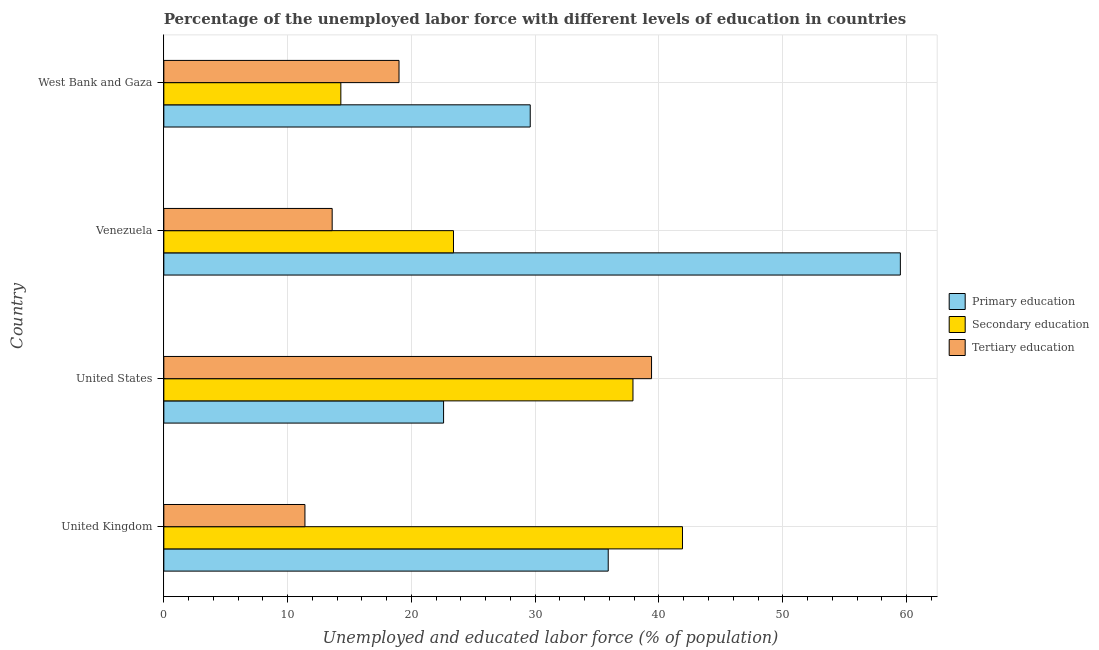How many groups of bars are there?
Make the answer very short. 4. Are the number of bars per tick equal to the number of legend labels?
Provide a succinct answer. Yes. Are the number of bars on each tick of the Y-axis equal?
Ensure brevity in your answer.  Yes. How many bars are there on the 2nd tick from the top?
Keep it short and to the point. 3. What is the percentage of labor force who received primary education in West Bank and Gaza?
Your response must be concise. 29.6. Across all countries, what is the maximum percentage of labor force who received tertiary education?
Make the answer very short. 39.4. Across all countries, what is the minimum percentage of labor force who received tertiary education?
Offer a terse response. 11.4. In which country was the percentage of labor force who received secondary education maximum?
Your answer should be very brief. United Kingdom. In which country was the percentage of labor force who received primary education minimum?
Your answer should be compact. United States. What is the total percentage of labor force who received tertiary education in the graph?
Your response must be concise. 83.4. What is the difference between the percentage of labor force who received primary education in Venezuela and that in West Bank and Gaza?
Provide a short and direct response. 29.9. What is the difference between the percentage of labor force who received secondary education in United Kingdom and the percentage of labor force who received tertiary education in West Bank and Gaza?
Ensure brevity in your answer.  22.9. What is the average percentage of labor force who received primary education per country?
Your answer should be very brief. 36.9. What is the difference between the percentage of labor force who received tertiary education and percentage of labor force who received secondary education in United Kingdom?
Your response must be concise. -30.5. In how many countries, is the percentage of labor force who received primary education greater than 50 %?
Ensure brevity in your answer.  1. What is the ratio of the percentage of labor force who received tertiary education in Venezuela to that in West Bank and Gaza?
Your answer should be compact. 0.72. What is the difference between the highest and the second highest percentage of labor force who received tertiary education?
Your response must be concise. 20.4. What is the difference between the highest and the lowest percentage of labor force who received tertiary education?
Ensure brevity in your answer.  28. Is the sum of the percentage of labor force who received secondary education in Venezuela and West Bank and Gaza greater than the maximum percentage of labor force who received tertiary education across all countries?
Give a very brief answer. No. What does the 3rd bar from the top in United States represents?
Your response must be concise. Primary education. What does the 2nd bar from the bottom in United States represents?
Keep it short and to the point. Secondary education. Is it the case that in every country, the sum of the percentage of labor force who received primary education and percentage of labor force who received secondary education is greater than the percentage of labor force who received tertiary education?
Make the answer very short. Yes. Are all the bars in the graph horizontal?
Keep it short and to the point. Yes. Does the graph contain any zero values?
Offer a very short reply. No. Does the graph contain grids?
Provide a succinct answer. Yes. How many legend labels are there?
Give a very brief answer. 3. What is the title of the graph?
Give a very brief answer. Percentage of the unemployed labor force with different levels of education in countries. Does "Labor Market" appear as one of the legend labels in the graph?
Keep it short and to the point. No. What is the label or title of the X-axis?
Ensure brevity in your answer.  Unemployed and educated labor force (% of population). What is the label or title of the Y-axis?
Your answer should be compact. Country. What is the Unemployed and educated labor force (% of population) of Primary education in United Kingdom?
Provide a succinct answer. 35.9. What is the Unemployed and educated labor force (% of population) in Secondary education in United Kingdom?
Ensure brevity in your answer.  41.9. What is the Unemployed and educated labor force (% of population) of Tertiary education in United Kingdom?
Make the answer very short. 11.4. What is the Unemployed and educated labor force (% of population) of Primary education in United States?
Ensure brevity in your answer.  22.6. What is the Unemployed and educated labor force (% of population) of Secondary education in United States?
Your answer should be compact. 37.9. What is the Unemployed and educated labor force (% of population) in Tertiary education in United States?
Your answer should be very brief. 39.4. What is the Unemployed and educated labor force (% of population) in Primary education in Venezuela?
Your answer should be very brief. 59.5. What is the Unemployed and educated labor force (% of population) of Secondary education in Venezuela?
Make the answer very short. 23.4. What is the Unemployed and educated labor force (% of population) of Tertiary education in Venezuela?
Ensure brevity in your answer.  13.6. What is the Unemployed and educated labor force (% of population) of Primary education in West Bank and Gaza?
Ensure brevity in your answer.  29.6. What is the Unemployed and educated labor force (% of population) in Secondary education in West Bank and Gaza?
Make the answer very short. 14.3. Across all countries, what is the maximum Unemployed and educated labor force (% of population) of Primary education?
Give a very brief answer. 59.5. Across all countries, what is the maximum Unemployed and educated labor force (% of population) of Secondary education?
Give a very brief answer. 41.9. Across all countries, what is the maximum Unemployed and educated labor force (% of population) of Tertiary education?
Make the answer very short. 39.4. Across all countries, what is the minimum Unemployed and educated labor force (% of population) in Primary education?
Your response must be concise. 22.6. Across all countries, what is the minimum Unemployed and educated labor force (% of population) in Secondary education?
Provide a short and direct response. 14.3. Across all countries, what is the minimum Unemployed and educated labor force (% of population) of Tertiary education?
Keep it short and to the point. 11.4. What is the total Unemployed and educated labor force (% of population) of Primary education in the graph?
Your answer should be compact. 147.6. What is the total Unemployed and educated labor force (% of population) of Secondary education in the graph?
Provide a succinct answer. 117.5. What is the total Unemployed and educated labor force (% of population) in Tertiary education in the graph?
Provide a short and direct response. 83.4. What is the difference between the Unemployed and educated labor force (% of population) in Primary education in United Kingdom and that in Venezuela?
Offer a very short reply. -23.6. What is the difference between the Unemployed and educated labor force (% of population) of Secondary education in United Kingdom and that in Venezuela?
Your answer should be very brief. 18.5. What is the difference between the Unemployed and educated labor force (% of population) in Tertiary education in United Kingdom and that in Venezuela?
Your response must be concise. -2.2. What is the difference between the Unemployed and educated labor force (% of population) in Primary education in United Kingdom and that in West Bank and Gaza?
Offer a terse response. 6.3. What is the difference between the Unemployed and educated labor force (% of population) of Secondary education in United Kingdom and that in West Bank and Gaza?
Make the answer very short. 27.6. What is the difference between the Unemployed and educated labor force (% of population) of Tertiary education in United Kingdom and that in West Bank and Gaza?
Your response must be concise. -7.6. What is the difference between the Unemployed and educated labor force (% of population) in Primary education in United States and that in Venezuela?
Ensure brevity in your answer.  -36.9. What is the difference between the Unemployed and educated labor force (% of population) of Secondary education in United States and that in Venezuela?
Give a very brief answer. 14.5. What is the difference between the Unemployed and educated labor force (% of population) of Tertiary education in United States and that in Venezuela?
Offer a terse response. 25.8. What is the difference between the Unemployed and educated labor force (% of population) of Primary education in United States and that in West Bank and Gaza?
Your answer should be compact. -7. What is the difference between the Unemployed and educated labor force (% of population) of Secondary education in United States and that in West Bank and Gaza?
Ensure brevity in your answer.  23.6. What is the difference between the Unemployed and educated labor force (% of population) in Tertiary education in United States and that in West Bank and Gaza?
Your answer should be very brief. 20.4. What is the difference between the Unemployed and educated labor force (% of population) in Primary education in Venezuela and that in West Bank and Gaza?
Provide a succinct answer. 29.9. What is the difference between the Unemployed and educated labor force (% of population) of Secondary education in Venezuela and that in West Bank and Gaza?
Make the answer very short. 9.1. What is the difference between the Unemployed and educated labor force (% of population) in Primary education in United Kingdom and the Unemployed and educated labor force (% of population) in Tertiary education in United States?
Keep it short and to the point. -3.5. What is the difference between the Unemployed and educated labor force (% of population) of Secondary education in United Kingdom and the Unemployed and educated labor force (% of population) of Tertiary education in United States?
Provide a succinct answer. 2.5. What is the difference between the Unemployed and educated labor force (% of population) of Primary education in United Kingdom and the Unemployed and educated labor force (% of population) of Tertiary education in Venezuela?
Give a very brief answer. 22.3. What is the difference between the Unemployed and educated labor force (% of population) of Secondary education in United Kingdom and the Unemployed and educated labor force (% of population) of Tertiary education in Venezuela?
Your answer should be compact. 28.3. What is the difference between the Unemployed and educated labor force (% of population) in Primary education in United Kingdom and the Unemployed and educated labor force (% of population) in Secondary education in West Bank and Gaza?
Offer a terse response. 21.6. What is the difference between the Unemployed and educated labor force (% of population) in Primary education in United Kingdom and the Unemployed and educated labor force (% of population) in Tertiary education in West Bank and Gaza?
Offer a very short reply. 16.9. What is the difference between the Unemployed and educated labor force (% of population) of Secondary education in United Kingdom and the Unemployed and educated labor force (% of population) of Tertiary education in West Bank and Gaza?
Your answer should be very brief. 22.9. What is the difference between the Unemployed and educated labor force (% of population) in Primary education in United States and the Unemployed and educated labor force (% of population) in Secondary education in Venezuela?
Make the answer very short. -0.8. What is the difference between the Unemployed and educated labor force (% of population) in Primary education in United States and the Unemployed and educated labor force (% of population) in Tertiary education in Venezuela?
Offer a very short reply. 9. What is the difference between the Unemployed and educated labor force (% of population) in Secondary education in United States and the Unemployed and educated labor force (% of population) in Tertiary education in Venezuela?
Your response must be concise. 24.3. What is the difference between the Unemployed and educated labor force (% of population) in Primary education in United States and the Unemployed and educated labor force (% of population) in Secondary education in West Bank and Gaza?
Make the answer very short. 8.3. What is the difference between the Unemployed and educated labor force (% of population) in Primary education in Venezuela and the Unemployed and educated labor force (% of population) in Secondary education in West Bank and Gaza?
Your response must be concise. 45.2. What is the difference between the Unemployed and educated labor force (% of population) in Primary education in Venezuela and the Unemployed and educated labor force (% of population) in Tertiary education in West Bank and Gaza?
Provide a succinct answer. 40.5. What is the average Unemployed and educated labor force (% of population) of Primary education per country?
Offer a very short reply. 36.9. What is the average Unemployed and educated labor force (% of population) in Secondary education per country?
Keep it short and to the point. 29.38. What is the average Unemployed and educated labor force (% of population) in Tertiary education per country?
Provide a succinct answer. 20.85. What is the difference between the Unemployed and educated labor force (% of population) of Secondary education and Unemployed and educated labor force (% of population) of Tertiary education in United Kingdom?
Give a very brief answer. 30.5. What is the difference between the Unemployed and educated labor force (% of population) in Primary education and Unemployed and educated labor force (% of population) in Secondary education in United States?
Make the answer very short. -15.3. What is the difference between the Unemployed and educated labor force (% of population) in Primary education and Unemployed and educated labor force (% of population) in Tertiary education in United States?
Make the answer very short. -16.8. What is the difference between the Unemployed and educated labor force (% of population) in Primary education and Unemployed and educated labor force (% of population) in Secondary education in Venezuela?
Give a very brief answer. 36.1. What is the difference between the Unemployed and educated labor force (% of population) in Primary education and Unemployed and educated labor force (% of population) in Tertiary education in Venezuela?
Ensure brevity in your answer.  45.9. What is the difference between the Unemployed and educated labor force (% of population) of Primary education and Unemployed and educated labor force (% of population) of Secondary education in West Bank and Gaza?
Your response must be concise. 15.3. What is the difference between the Unemployed and educated labor force (% of population) in Secondary education and Unemployed and educated labor force (% of population) in Tertiary education in West Bank and Gaza?
Make the answer very short. -4.7. What is the ratio of the Unemployed and educated labor force (% of population) of Primary education in United Kingdom to that in United States?
Your response must be concise. 1.59. What is the ratio of the Unemployed and educated labor force (% of population) in Secondary education in United Kingdom to that in United States?
Provide a short and direct response. 1.11. What is the ratio of the Unemployed and educated labor force (% of population) of Tertiary education in United Kingdom to that in United States?
Your answer should be very brief. 0.29. What is the ratio of the Unemployed and educated labor force (% of population) of Primary education in United Kingdom to that in Venezuela?
Provide a succinct answer. 0.6. What is the ratio of the Unemployed and educated labor force (% of population) of Secondary education in United Kingdom to that in Venezuela?
Give a very brief answer. 1.79. What is the ratio of the Unemployed and educated labor force (% of population) in Tertiary education in United Kingdom to that in Venezuela?
Your response must be concise. 0.84. What is the ratio of the Unemployed and educated labor force (% of population) of Primary education in United Kingdom to that in West Bank and Gaza?
Your answer should be compact. 1.21. What is the ratio of the Unemployed and educated labor force (% of population) in Secondary education in United Kingdom to that in West Bank and Gaza?
Your answer should be very brief. 2.93. What is the ratio of the Unemployed and educated labor force (% of population) of Tertiary education in United Kingdom to that in West Bank and Gaza?
Your answer should be compact. 0.6. What is the ratio of the Unemployed and educated labor force (% of population) in Primary education in United States to that in Venezuela?
Your answer should be compact. 0.38. What is the ratio of the Unemployed and educated labor force (% of population) of Secondary education in United States to that in Venezuela?
Offer a very short reply. 1.62. What is the ratio of the Unemployed and educated labor force (% of population) in Tertiary education in United States to that in Venezuela?
Provide a short and direct response. 2.9. What is the ratio of the Unemployed and educated labor force (% of population) in Primary education in United States to that in West Bank and Gaza?
Provide a succinct answer. 0.76. What is the ratio of the Unemployed and educated labor force (% of population) of Secondary education in United States to that in West Bank and Gaza?
Your response must be concise. 2.65. What is the ratio of the Unemployed and educated labor force (% of population) in Tertiary education in United States to that in West Bank and Gaza?
Ensure brevity in your answer.  2.07. What is the ratio of the Unemployed and educated labor force (% of population) of Primary education in Venezuela to that in West Bank and Gaza?
Your response must be concise. 2.01. What is the ratio of the Unemployed and educated labor force (% of population) of Secondary education in Venezuela to that in West Bank and Gaza?
Provide a succinct answer. 1.64. What is the ratio of the Unemployed and educated labor force (% of population) in Tertiary education in Venezuela to that in West Bank and Gaza?
Your response must be concise. 0.72. What is the difference between the highest and the second highest Unemployed and educated labor force (% of population) of Primary education?
Make the answer very short. 23.6. What is the difference between the highest and the second highest Unemployed and educated labor force (% of population) of Tertiary education?
Offer a very short reply. 20.4. What is the difference between the highest and the lowest Unemployed and educated labor force (% of population) of Primary education?
Give a very brief answer. 36.9. What is the difference between the highest and the lowest Unemployed and educated labor force (% of population) in Secondary education?
Give a very brief answer. 27.6. What is the difference between the highest and the lowest Unemployed and educated labor force (% of population) of Tertiary education?
Offer a terse response. 28. 